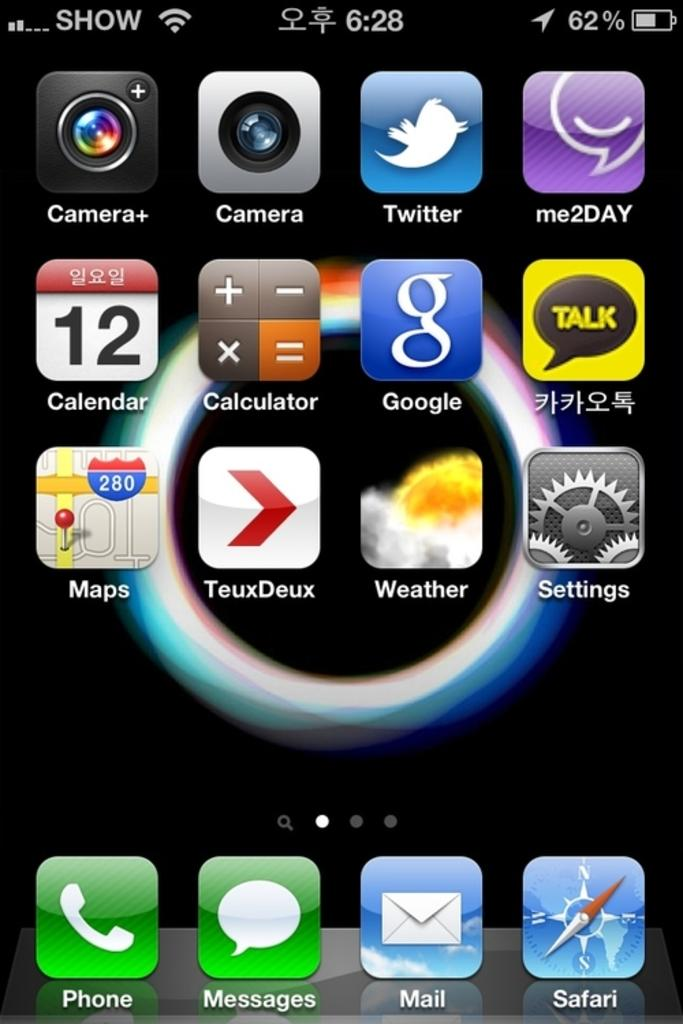<image>
Relay a brief, clear account of the picture shown. Phone screen that has the time at 6:28 and the battery life at 62%. 